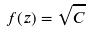Convert formula to latex. <formula><loc_0><loc_0><loc_500><loc_500>f ( z ) = \sqrt { C }</formula> 